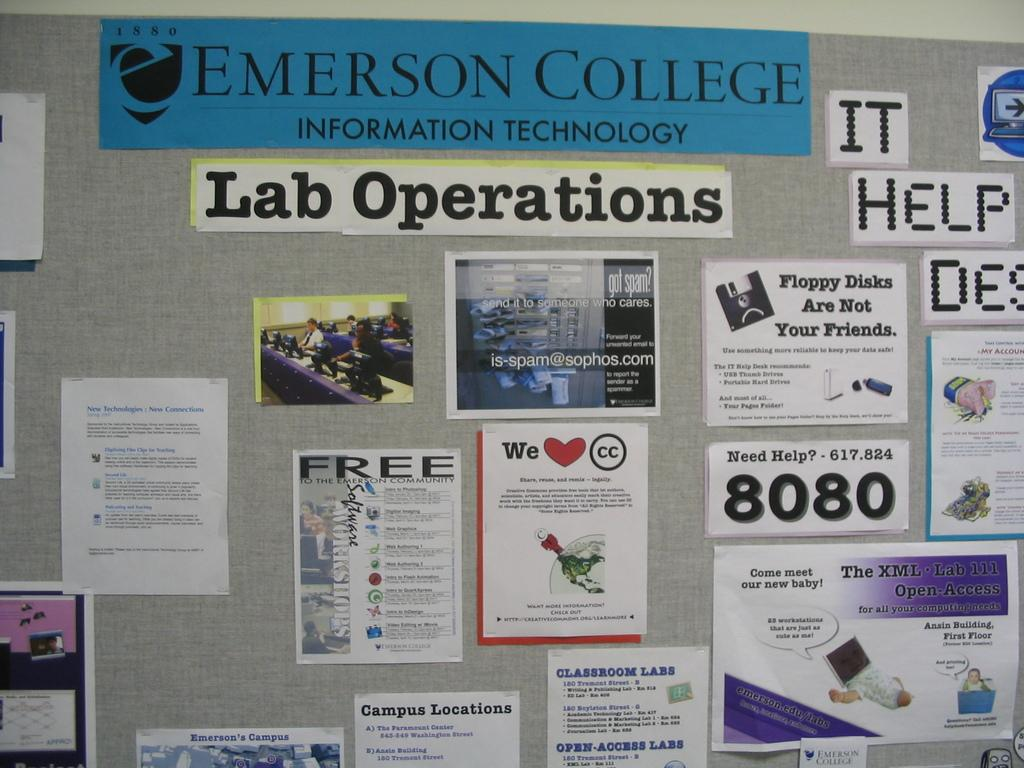<image>
Share a concise interpretation of the image provided. a cork board wit hthe title emerson college pinned to the top with lab operations pinned beneath. 